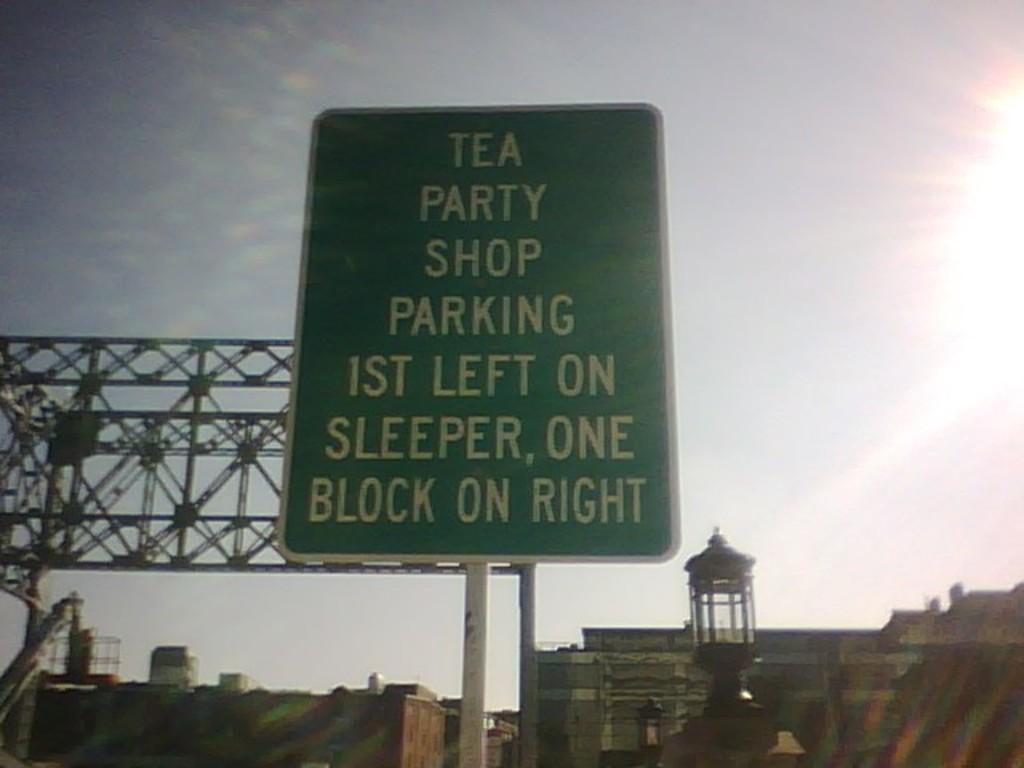What shop is the sign directing parking to?
Ensure brevity in your answer.  Tea party shop. 